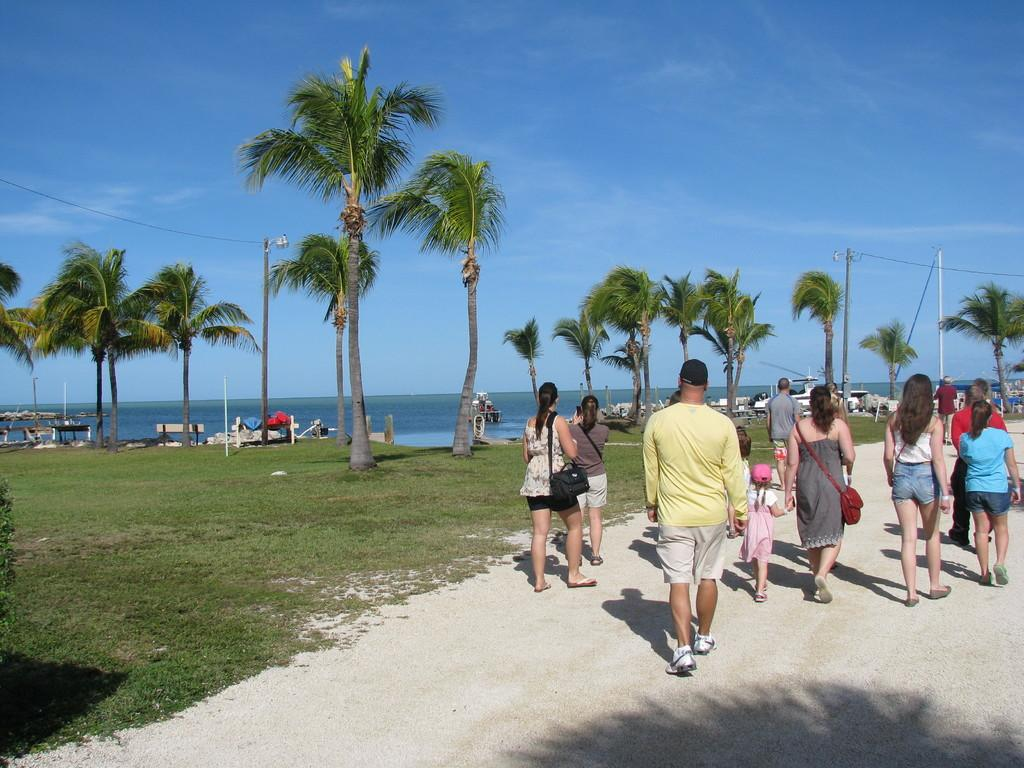What can be seen in the right corner of the image? There are people standing in the right corner of the image. What is visible in the background of the image? There are trees and boats in the background of the image, along with water. What type of dress is being worn by the people in the room in the image? There is no room present in the image, and the people standing in the right corner are not wearing any dresses. 